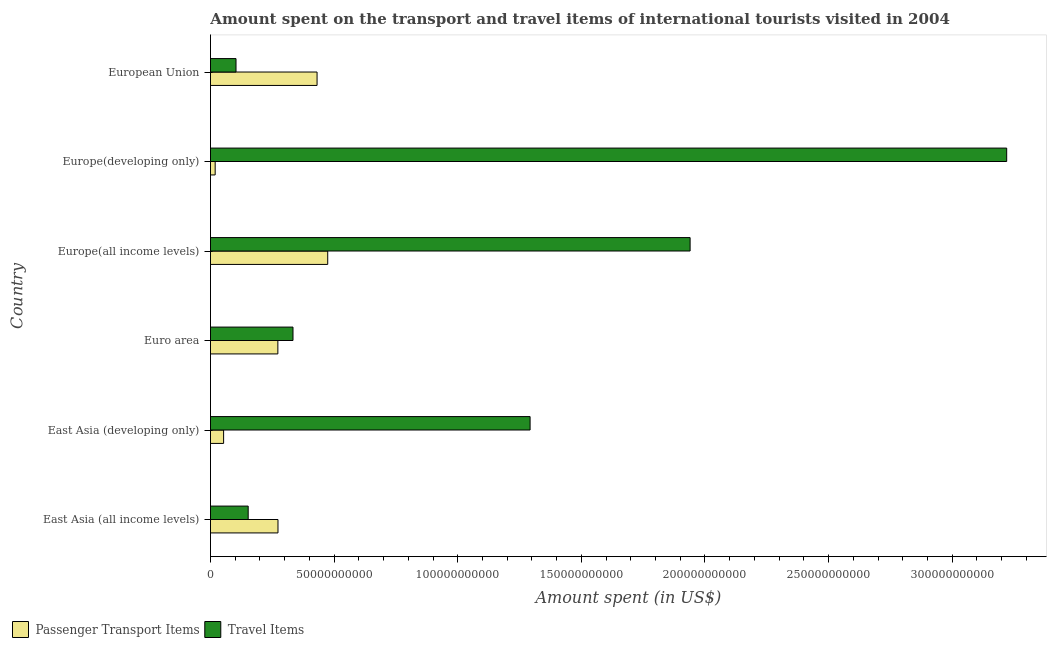How many groups of bars are there?
Ensure brevity in your answer.  6. Are the number of bars per tick equal to the number of legend labels?
Give a very brief answer. Yes. How many bars are there on the 4th tick from the top?
Offer a very short reply. 2. What is the label of the 3rd group of bars from the top?
Provide a succinct answer. Europe(all income levels). In how many cases, is the number of bars for a given country not equal to the number of legend labels?
Offer a terse response. 0. What is the amount spent on passenger transport items in East Asia (all income levels)?
Your response must be concise. 2.73e+1. Across all countries, what is the maximum amount spent in travel items?
Your answer should be compact. 3.22e+11. Across all countries, what is the minimum amount spent on passenger transport items?
Offer a very short reply. 1.90e+09. In which country was the amount spent on passenger transport items maximum?
Provide a succinct answer. Europe(all income levels). In which country was the amount spent in travel items minimum?
Provide a succinct answer. European Union. What is the total amount spent in travel items in the graph?
Ensure brevity in your answer.  7.04e+11. What is the difference between the amount spent on passenger transport items in East Asia (all income levels) and that in East Asia (developing only)?
Provide a succinct answer. 2.20e+1. What is the difference between the amount spent on passenger transport items in Europe(all income levels) and the amount spent in travel items in East Asia (developing only)?
Your response must be concise. -8.19e+1. What is the average amount spent in travel items per country?
Offer a terse response. 1.17e+11. What is the difference between the amount spent in travel items and amount spent on passenger transport items in Euro area?
Make the answer very short. 6.12e+09. In how many countries, is the amount spent in travel items greater than 80000000000 US$?
Your answer should be compact. 3. What is the ratio of the amount spent in travel items in East Asia (developing only) to that in Europe(developing only)?
Provide a succinct answer. 0.4. Is the difference between the amount spent on passenger transport items in East Asia (all income levels) and East Asia (developing only) greater than the difference between the amount spent in travel items in East Asia (all income levels) and East Asia (developing only)?
Your answer should be compact. Yes. What is the difference between the highest and the second highest amount spent in travel items?
Give a very brief answer. 1.28e+11. What is the difference between the highest and the lowest amount spent on passenger transport items?
Your answer should be compact. 4.55e+1. Is the sum of the amount spent on passenger transport items in East Asia (all income levels) and Europe(developing only) greater than the maximum amount spent in travel items across all countries?
Offer a terse response. No. What does the 1st bar from the top in East Asia (developing only) represents?
Offer a terse response. Travel Items. What does the 1st bar from the bottom in Europe(all income levels) represents?
Keep it short and to the point. Passenger Transport Items. How many bars are there?
Your response must be concise. 12. Are all the bars in the graph horizontal?
Keep it short and to the point. Yes. Are the values on the major ticks of X-axis written in scientific E-notation?
Ensure brevity in your answer.  No. Does the graph contain any zero values?
Offer a terse response. No. Where does the legend appear in the graph?
Offer a terse response. Bottom left. How many legend labels are there?
Provide a succinct answer. 2. How are the legend labels stacked?
Ensure brevity in your answer.  Horizontal. What is the title of the graph?
Keep it short and to the point. Amount spent on the transport and travel items of international tourists visited in 2004. What is the label or title of the X-axis?
Your response must be concise. Amount spent (in US$). What is the label or title of the Y-axis?
Your answer should be compact. Country. What is the Amount spent (in US$) of Passenger Transport Items in East Asia (all income levels)?
Your answer should be very brief. 2.73e+1. What is the Amount spent (in US$) of Travel Items in East Asia (all income levels)?
Your response must be concise. 1.53e+1. What is the Amount spent (in US$) of Passenger Transport Items in East Asia (developing only)?
Ensure brevity in your answer.  5.32e+09. What is the Amount spent (in US$) of Travel Items in East Asia (developing only)?
Provide a succinct answer. 1.29e+11. What is the Amount spent (in US$) of Passenger Transport Items in Euro area?
Your answer should be compact. 2.73e+1. What is the Amount spent (in US$) in Travel Items in Euro area?
Keep it short and to the point. 3.34e+1. What is the Amount spent (in US$) in Passenger Transport Items in Europe(all income levels)?
Your answer should be very brief. 4.74e+1. What is the Amount spent (in US$) in Travel Items in Europe(all income levels)?
Your response must be concise. 1.94e+11. What is the Amount spent (in US$) in Passenger Transport Items in Europe(developing only)?
Give a very brief answer. 1.90e+09. What is the Amount spent (in US$) in Travel Items in Europe(developing only)?
Offer a terse response. 3.22e+11. What is the Amount spent (in US$) of Passenger Transport Items in European Union?
Provide a succinct answer. 4.31e+1. What is the Amount spent (in US$) in Travel Items in European Union?
Provide a succinct answer. 1.03e+1. Across all countries, what is the maximum Amount spent (in US$) of Passenger Transport Items?
Give a very brief answer. 4.74e+1. Across all countries, what is the maximum Amount spent (in US$) in Travel Items?
Make the answer very short. 3.22e+11. Across all countries, what is the minimum Amount spent (in US$) in Passenger Transport Items?
Your answer should be compact. 1.90e+09. Across all countries, what is the minimum Amount spent (in US$) of Travel Items?
Provide a succinct answer. 1.03e+1. What is the total Amount spent (in US$) in Passenger Transport Items in the graph?
Offer a very short reply. 1.52e+11. What is the total Amount spent (in US$) in Travel Items in the graph?
Give a very brief answer. 7.04e+11. What is the difference between the Amount spent (in US$) of Passenger Transport Items in East Asia (all income levels) and that in East Asia (developing only)?
Make the answer very short. 2.20e+1. What is the difference between the Amount spent (in US$) in Travel Items in East Asia (all income levels) and that in East Asia (developing only)?
Make the answer very short. -1.14e+11. What is the difference between the Amount spent (in US$) in Passenger Transport Items in East Asia (all income levels) and that in Euro area?
Your answer should be very brief. 4.89e+07. What is the difference between the Amount spent (in US$) in Travel Items in East Asia (all income levels) and that in Euro area?
Make the answer very short. -1.81e+1. What is the difference between the Amount spent (in US$) in Passenger Transport Items in East Asia (all income levels) and that in Europe(all income levels)?
Provide a short and direct response. -2.01e+1. What is the difference between the Amount spent (in US$) in Travel Items in East Asia (all income levels) and that in Europe(all income levels)?
Your response must be concise. -1.79e+11. What is the difference between the Amount spent (in US$) of Passenger Transport Items in East Asia (all income levels) and that in Europe(developing only)?
Keep it short and to the point. 2.54e+1. What is the difference between the Amount spent (in US$) of Travel Items in East Asia (all income levels) and that in Europe(developing only)?
Your answer should be compact. -3.07e+11. What is the difference between the Amount spent (in US$) of Passenger Transport Items in East Asia (all income levels) and that in European Union?
Keep it short and to the point. -1.58e+1. What is the difference between the Amount spent (in US$) in Travel Items in East Asia (all income levels) and that in European Union?
Your answer should be very brief. 4.92e+09. What is the difference between the Amount spent (in US$) of Passenger Transport Items in East Asia (developing only) and that in Euro area?
Your response must be concise. -2.19e+1. What is the difference between the Amount spent (in US$) of Travel Items in East Asia (developing only) and that in Euro area?
Your answer should be compact. 9.59e+1. What is the difference between the Amount spent (in US$) of Passenger Transport Items in East Asia (developing only) and that in Europe(all income levels)?
Your answer should be very brief. -4.21e+1. What is the difference between the Amount spent (in US$) in Travel Items in East Asia (developing only) and that in Europe(all income levels)?
Offer a terse response. -6.47e+1. What is the difference between the Amount spent (in US$) in Passenger Transport Items in East Asia (developing only) and that in Europe(developing only)?
Ensure brevity in your answer.  3.42e+09. What is the difference between the Amount spent (in US$) in Travel Items in East Asia (developing only) and that in Europe(developing only)?
Your answer should be very brief. -1.93e+11. What is the difference between the Amount spent (in US$) of Passenger Transport Items in East Asia (developing only) and that in European Union?
Provide a succinct answer. -3.78e+1. What is the difference between the Amount spent (in US$) in Travel Items in East Asia (developing only) and that in European Union?
Keep it short and to the point. 1.19e+11. What is the difference between the Amount spent (in US$) in Passenger Transport Items in Euro area and that in Europe(all income levels)?
Your response must be concise. -2.02e+1. What is the difference between the Amount spent (in US$) in Travel Items in Euro area and that in Europe(all income levels)?
Ensure brevity in your answer.  -1.61e+11. What is the difference between the Amount spent (in US$) in Passenger Transport Items in Euro area and that in Europe(developing only)?
Offer a terse response. 2.54e+1. What is the difference between the Amount spent (in US$) of Travel Items in Euro area and that in Europe(developing only)?
Keep it short and to the point. -2.89e+11. What is the difference between the Amount spent (in US$) of Passenger Transport Items in Euro area and that in European Union?
Provide a short and direct response. -1.59e+1. What is the difference between the Amount spent (in US$) in Travel Items in Euro area and that in European Union?
Offer a terse response. 2.30e+1. What is the difference between the Amount spent (in US$) of Passenger Transport Items in Europe(all income levels) and that in Europe(developing only)?
Provide a succinct answer. 4.55e+1. What is the difference between the Amount spent (in US$) in Travel Items in Europe(all income levels) and that in Europe(developing only)?
Your answer should be compact. -1.28e+11. What is the difference between the Amount spent (in US$) in Passenger Transport Items in Europe(all income levels) and that in European Union?
Your answer should be very brief. 4.31e+09. What is the difference between the Amount spent (in US$) of Travel Items in Europe(all income levels) and that in European Union?
Offer a terse response. 1.84e+11. What is the difference between the Amount spent (in US$) in Passenger Transport Items in Europe(developing only) and that in European Union?
Ensure brevity in your answer.  -4.12e+1. What is the difference between the Amount spent (in US$) of Travel Items in Europe(developing only) and that in European Union?
Ensure brevity in your answer.  3.12e+11. What is the difference between the Amount spent (in US$) of Passenger Transport Items in East Asia (all income levels) and the Amount spent (in US$) of Travel Items in East Asia (developing only)?
Offer a very short reply. -1.02e+11. What is the difference between the Amount spent (in US$) of Passenger Transport Items in East Asia (all income levels) and the Amount spent (in US$) of Travel Items in Euro area?
Keep it short and to the point. -6.07e+09. What is the difference between the Amount spent (in US$) in Passenger Transport Items in East Asia (all income levels) and the Amount spent (in US$) in Travel Items in Europe(all income levels)?
Offer a very short reply. -1.67e+11. What is the difference between the Amount spent (in US$) in Passenger Transport Items in East Asia (all income levels) and the Amount spent (in US$) in Travel Items in Europe(developing only)?
Make the answer very short. -2.95e+11. What is the difference between the Amount spent (in US$) in Passenger Transport Items in East Asia (all income levels) and the Amount spent (in US$) in Travel Items in European Union?
Give a very brief answer. 1.70e+1. What is the difference between the Amount spent (in US$) in Passenger Transport Items in East Asia (developing only) and the Amount spent (in US$) in Travel Items in Euro area?
Make the answer very short. -2.81e+1. What is the difference between the Amount spent (in US$) of Passenger Transport Items in East Asia (developing only) and the Amount spent (in US$) of Travel Items in Europe(all income levels)?
Keep it short and to the point. -1.89e+11. What is the difference between the Amount spent (in US$) of Passenger Transport Items in East Asia (developing only) and the Amount spent (in US$) of Travel Items in Europe(developing only)?
Your answer should be compact. -3.17e+11. What is the difference between the Amount spent (in US$) of Passenger Transport Items in East Asia (developing only) and the Amount spent (in US$) of Travel Items in European Union?
Give a very brief answer. -5.01e+09. What is the difference between the Amount spent (in US$) in Passenger Transport Items in Euro area and the Amount spent (in US$) in Travel Items in Europe(all income levels)?
Provide a succinct answer. -1.67e+11. What is the difference between the Amount spent (in US$) in Passenger Transport Items in Euro area and the Amount spent (in US$) in Travel Items in Europe(developing only)?
Your answer should be very brief. -2.95e+11. What is the difference between the Amount spent (in US$) in Passenger Transport Items in Euro area and the Amount spent (in US$) in Travel Items in European Union?
Give a very brief answer. 1.69e+1. What is the difference between the Amount spent (in US$) in Passenger Transport Items in Europe(all income levels) and the Amount spent (in US$) in Travel Items in Europe(developing only)?
Your answer should be very brief. -2.75e+11. What is the difference between the Amount spent (in US$) of Passenger Transport Items in Europe(all income levels) and the Amount spent (in US$) of Travel Items in European Union?
Ensure brevity in your answer.  3.71e+1. What is the difference between the Amount spent (in US$) of Passenger Transport Items in Europe(developing only) and the Amount spent (in US$) of Travel Items in European Union?
Provide a succinct answer. -8.43e+09. What is the average Amount spent (in US$) in Passenger Transport Items per country?
Ensure brevity in your answer.  2.54e+1. What is the average Amount spent (in US$) in Travel Items per country?
Provide a succinct answer. 1.17e+11. What is the difference between the Amount spent (in US$) in Passenger Transport Items and Amount spent (in US$) in Travel Items in East Asia (all income levels)?
Your response must be concise. 1.21e+1. What is the difference between the Amount spent (in US$) in Passenger Transport Items and Amount spent (in US$) in Travel Items in East Asia (developing only)?
Offer a very short reply. -1.24e+11. What is the difference between the Amount spent (in US$) of Passenger Transport Items and Amount spent (in US$) of Travel Items in Euro area?
Offer a terse response. -6.12e+09. What is the difference between the Amount spent (in US$) of Passenger Transport Items and Amount spent (in US$) of Travel Items in Europe(all income levels)?
Your response must be concise. -1.47e+11. What is the difference between the Amount spent (in US$) of Passenger Transport Items and Amount spent (in US$) of Travel Items in Europe(developing only)?
Give a very brief answer. -3.20e+11. What is the difference between the Amount spent (in US$) of Passenger Transport Items and Amount spent (in US$) of Travel Items in European Union?
Give a very brief answer. 3.28e+1. What is the ratio of the Amount spent (in US$) of Passenger Transport Items in East Asia (all income levels) to that in East Asia (developing only)?
Offer a very short reply. 5.14. What is the ratio of the Amount spent (in US$) in Travel Items in East Asia (all income levels) to that in East Asia (developing only)?
Your answer should be compact. 0.12. What is the ratio of the Amount spent (in US$) of Travel Items in East Asia (all income levels) to that in Euro area?
Give a very brief answer. 0.46. What is the ratio of the Amount spent (in US$) of Passenger Transport Items in East Asia (all income levels) to that in Europe(all income levels)?
Ensure brevity in your answer.  0.58. What is the ratio of the Amount spent (in US$) in Travel Items in East Asia (all income levels) to that in Europe(all income levels)?
Provide a short and direct response. 0.08. What is the ratio of the Amount spent (in US$) of Passenger Transport Items in East Asia (all income levels) to that in Europe(developing only)?
Your response must be concise. 14.38. What is the ratio of the Amount spent (in US$) of Travel Items in East Asia (all income levels) to that in Europe(developing only)?
Make the answer very short. 0.05. What is the ratio of the Amount spent (in US$) of Passenger Transport Items in East Asia (all income levels) to that in European Union?
Your answer should be compact. 0.63. What is the ratio of the Amount spent (in US$) in Travel Items in East Asia (all income levels) to that in European Union?
Your answer should be very brief. 1.48. What is the ratio of the Amount spent (in US$) in Passenger Transport Items in East Asia (developing only) to that in Euro area?
Your response must be concise. 0.2. What is the ratio of the Amount spent (in US$) of Travel Items in East Asia (developing only) to that in Euro area?
Provide a short and direct response. 3.87. What is the ratio of the Amount spent (in US$) in Passenger Transport Items in East Asia (developing only) to that in Europe(all income levels)?
Your answer should be compact. 0.11. What is the ratio of the Amount spent (in US$) of Travel Items in East Asia (developing only) to that in Europe(all income levels)?
Give a very brief answer. 0.67. What is the ratio of the Amount spent (in US$) in Passenger Transport Items in East Asia (developing only) to that in Europe(developing only)?
Keep it short and to the point. 2.8. What is the ratio of the Amount spent (in US$) in Travel Items in East Asia (developing only) to that in Europe(developing only)?
Ensure brevity in your answer.  0.4. What is the ratio of the Amount spent (in US$) in Passenger Transport Items in East Asia (developing only) to that in European Union?
Your answer should be very brief. 0.12. What is the ratio of the Amount spent (in US$) of Travel Items in East Asia (developing only) to that in European Union?
Your response must be concise. 12.51. What is the ratio of the Amount spent (in US$) of Passenger Transport Items in Euro area to that in Europe(all income levels)?
Your response must be concise. 0.57. What is the ratio of the Amount spent (in US$) of Travel Items in Euro area to that in Europe(all income levels)?
Your answer should be very brief. 0.17. What is the ratio of the Amount spent (in US$) of Passenger Transport Items in Euro area to that in Europe(developing only)?
Your answer should be compact. 14.35. What is the ratio of the Amount spent (in US$) in Travel Items in Euro area to that in Europe(developing only)?
Your answer should be very brief. 0.1. What is the ratio of the Amount spent (in US$) of Passenger Transport Items in Euro area to that in European Union?
Make the answer very short. 0.63. What is the ratio of the Amount spent (in US$) in Travel Items in Euro area to that in European Union?
Your answer should be very brief. 3.23. What is the ratio of the Amount spent (in US$) of Passenger Transport Items in Europe(all income levels) to that in Europe(developing only)?
Offer a very short reply. 24.97. What is the ratio of the Amount spent (in US$) of Travel Items in Europe(all income levels) to that in Europe(developing only)?
Offer a terse response. 0.6. What is the ratio of the Amount spent (in US$) of Passenger Transport Items in Europe(all income levels) to that in European Union?
Give a very brief answer. 1.1. What is the ratio of the Amount spent (in US$) of Travel Items in Europe(all income levels) to that in European Union?
Ensure brevity in your answer.  18.78. What is the ratio of the Amount spent (in US$) in Passenger Transport Items in Europe(developing only) to that in European Union?
Keep it short and to the point. 0.04. What is the ratio of the Amount spent (in US$) in Travel Items in Europe(developing only) to that in European Union?
Provide a short and direct response. 31.18. What is the difference between the highest and the second highest Amount spent (in US$) of Passenger Transport Items?
Keep it short and to the point. 4.31e+09. What is the difference between the highest and the second highest Amount spent (in US$) in Travel Items?
Offer a terse response. 1.28e+11. What is the difference between the highest and the lowest Amount spent (in US$) in Passenger Transport Items?
Offer a terse response. 4.55e+1. What is the difference between the highest and the lowest Amount spent (in US$) in Travel Items?
Your response must be concise. 3.12e+11. 